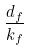Convert formula to latex. <formula><loc_0><loc_0><loc_500><loc_500>\frac { d _ { f } } { k _ { f } }</formula> 